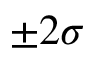Convert formula to latex. <formula><loc_0><loc_0><loc_500><loc_500>\pm 2 \sigma</formula> 